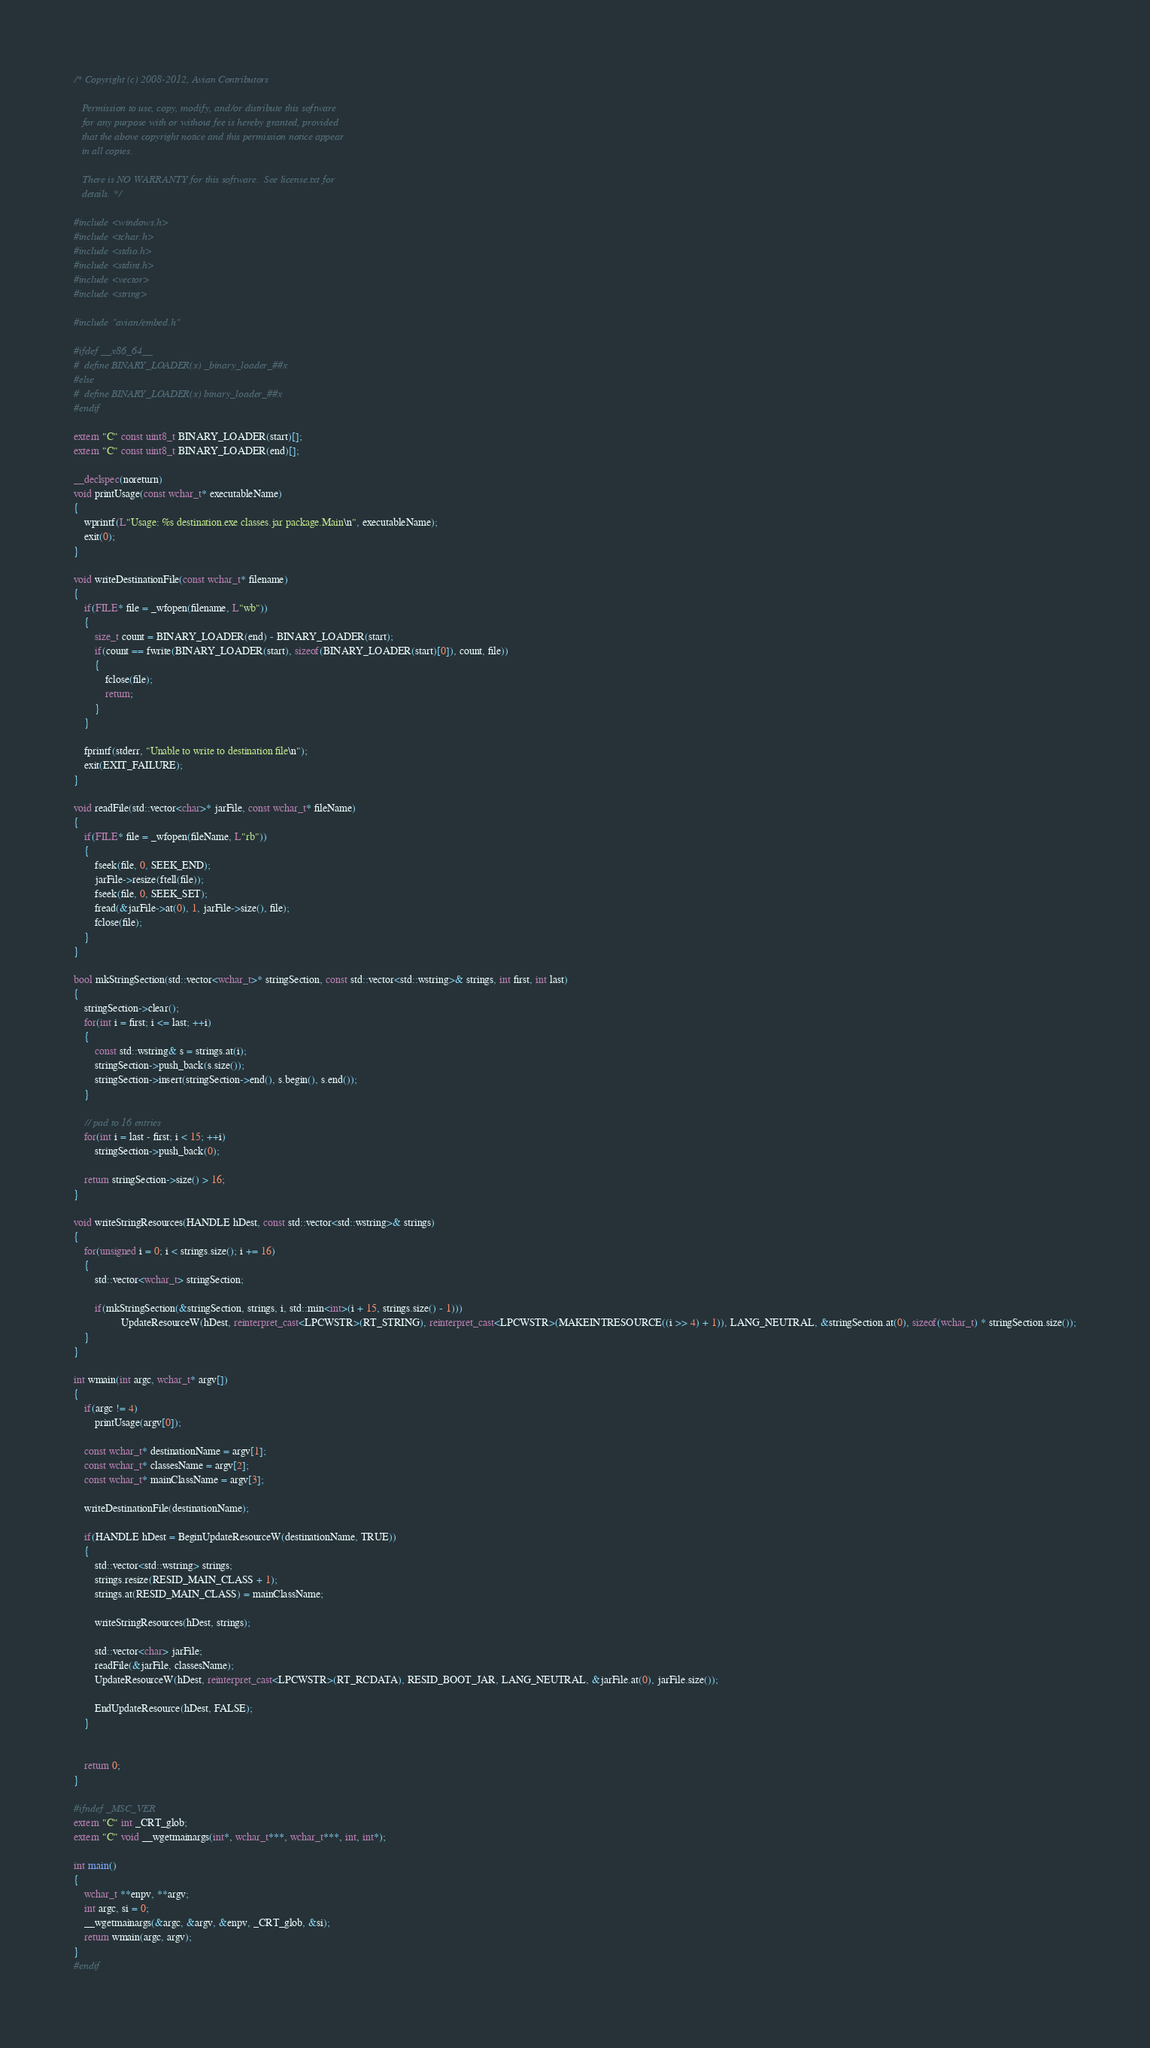<code> <loc_0><loc_0><loc_500><loc_500><_C++_>/* Copyright (c) 2008-2012, Avian Contributors

   Permission to use, copy, modify, and/or distribute this software
   for any purpose with or without fee is hereby granted, provided
   that the above copyright notice and this permission notice appear
   in all copies.

   There is NO WARRANTY for this software.  See license.txt for
   details. */

#include <windows.h>
#include <tchar.h>
#include <stdio.h>
#include <stdint.h>
#include <vector>
#include <string>

#include "avian/embed.h"

#ifdef __x86_64__
#  define BINARY_LOADER(x) _binary_loader_##x
#else
#  define BINARY_LOADER(x) binary_loader_##x
#endif

extern "C" const uint8_t BINARY_LOADER(start)[];
extern "C" const uint8_t BINARY_LOADER(end)[];

__declspec(noreturn)
void printUsage(const wchar_t* executableName)
{
	wprintf(L"Usage: %s destination.exe classes.jar package.Main\n", executableName);
	exit(0);
}

void writeDestinationFile(const wchar_t* filename)
{
	if(FILE* file = _wfopen(filename, L"wb"))
	{
		size_t count = BINARY_LOADER(end) - BINARY_LOADER(start);
		if(count == fwrite(BINARY_LOADER(start), sizeof(BINARY_LOADER(start)[0]), count, file))
		{
			fclose(file);
			return;
		}
	}
	
	fprintf(stderr, "Unable to write to destination file\n");
	exit(EXIT_FAILURE);
}

void readFile(std::vector<char>* jarFile, const wchar_t* fileName)
{
	if(FILE* file = _wfopen(fileName, L"rb"))
	{
		fseek(file, 0, SEEK_END);
		jarFile->resize(ftell(file));
		fseek(file, 0, SEEK_SET);
		fread(&jarFile->at(0), 1, jarFile->size(), file);
		fclose(file);
	}
}

bool mkStringSection(std::vector<wchar_t>* stringSection, const std::vector<std::wstring>& strings, int first, int last)
{
	stringSection->clear();
	for(int i = first; i <= last; ++i)
	{
		const std::wstring& s = strings.at(i);
		stringSection->push_back(s.size());
		stringSection->insert(stringSection->end(), s.begin(), s.end());
	}

	// pad to 16 entries
	for(int i = last - first; i < 15; ++i)
		stringSection->push_back(0);

	return stringSection->size() > 16;
}

void writeStringResources(HANDLE hDest, const std::vector<std::wstring>& strings)
{
	for(unsigned i = 0; i < strings.size(); i += 16)
	{
		std::vector<wchar_t> stringSection;

		if(mkStringSection(&stringSection, strings, i, std::min<int>(i + 15, strings.size() - 1)))
                  UpdateResourceW(hDest, reinterpret_cast<LPCWSTR>(RT_STRING), reinterpret_cast<LPCWSTR>(MAKEINTRESOURCE((i >> 4) + 1)), LANG_NEUTRAL, &stringSection.at(0), sizeof(wchar_t) * stringSection.size());
	}
}

int wmain(int argc, wchar_t* argv[])
{
	if(argc != 4)
		printUsage(argv[0]);

	const wchar_t* destinationName = argv[1];
	const wchar_t* classesName = argv[2];
	const wchar_t* mainClassName = argv[3];
	
	writeDestinationFile(destinationName);
	
	if(HANDLE hDest = BeginUpdateResourceW(destinationName, TRUE))
	{
		std::vector<std::wstring> strings;
		strings.resize(RESID_MAIN_CLASS + 1);
		strings.at(RESID_MAIN_CLASS) = mainClassName;
		
		writeStringResources(hDest, strings);
		
		std::vector<char> jarFile;
		readFile(&jarFile, classesName);
		UpdateResourceW(hDest, reinterpret_cast<LPCWSTR>(RT_RCDATA), RESID_BOOT_JAR, LANG_NEUTRAL, &jarFile.at(0), jarFile.size());
		
		EndUpdateResource(hDest, FALSE);
	}
	

	return 0;
}

#ifndef _MSC_VER
extern "C" int _CRT_glob;
extern "C" void __wgetmainargs(int*, wchar_t***, wchar_t***, int, int*);

int main()
{
	wchar_t **enpv, **argv;
	int argc, si = 0;
	__wgetmainargs(&argc, &argv, &enpv, _CRT_glob, &si);
	return wmain(argc, argv);
}
#endif
</code> 